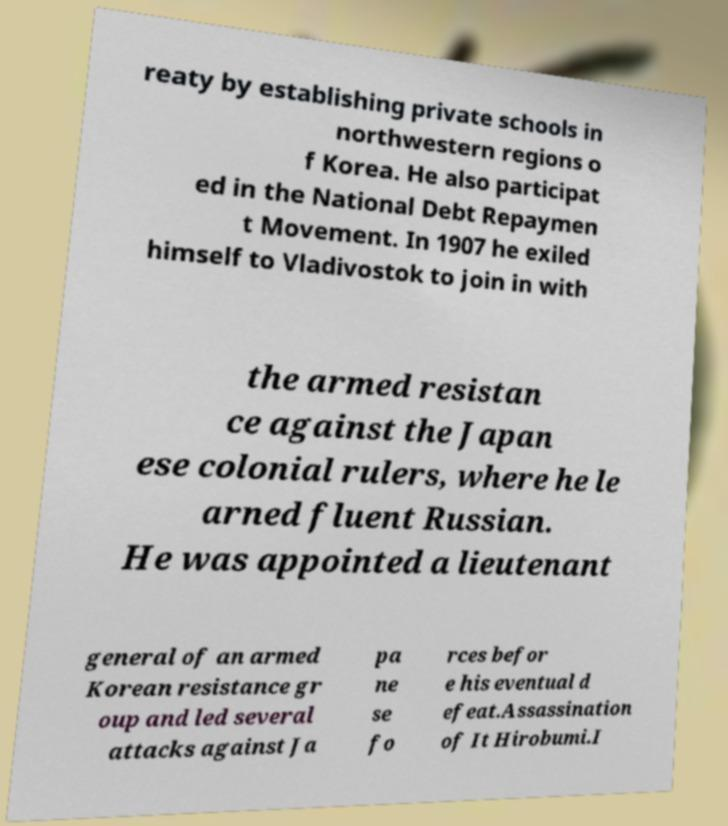Please identify and transcribe the text found in this image. reaty by establishing private schools in northwestern regions o f Korea. He also participat ed in the National Debt Repaymen t Movement. In 1907 he exiled himself to Vladivostok to join in with the armed resistan ce against the Japan ese colonial rulers, where he le arned fluent Russian. He was appointed a lieutenant general of an armed Korean resistance gr oup and led several attacks against Ja pa ne se fo rces befor e his eventual d efeat.Assassination of It Hirobumi.I 